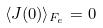<formula> <loc_0><loc_0><loc_500><loc_500>\langle J ( 0 ) \rangle _ { F _ { e } } = 0</formula> 